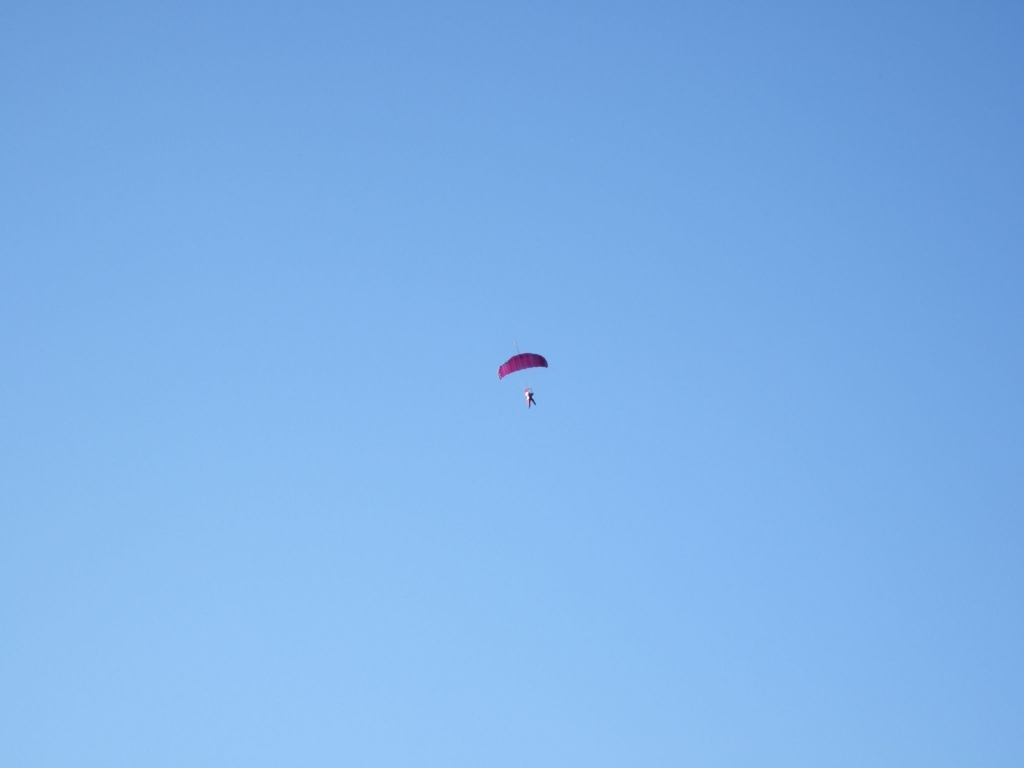Are there some noise points present? Yes, there are some noise points present in the sky. These are likely caused by digital or sensor noise due to the camera's sensitivity setting. Reducing the ISO setting or applying a noise reduction filter might help to clear up the image. 